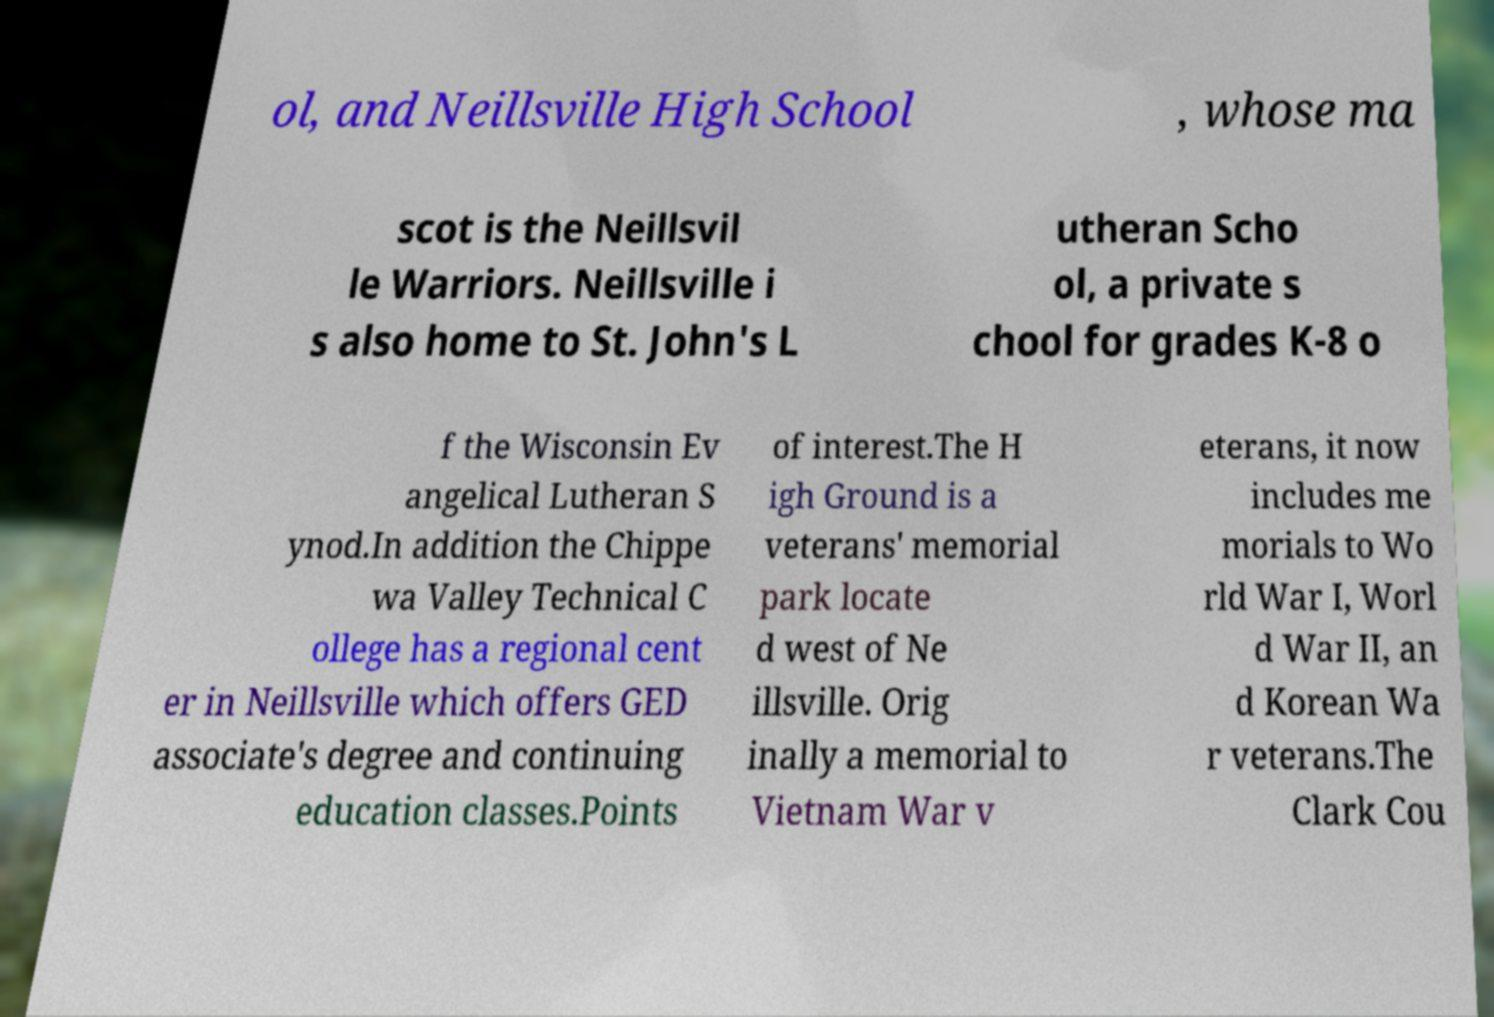Could you assist in decoding the text presented in this image and type it out clearly? ol, and Neillsville High School , whose ma scot is the Neillsvil le Warriors. Neillsville i s also home to St. John's L utheran Scho ol, a private s chool for grades K-8 o f the Wisconsin Ev angelical Lutheran S ynod.In addition the Chippe wa Valley Technical C ollege has a regional cent er in Neillsville which offers GED associate's degree and continuing education classes.Points of interest.The H igh Ground is a veterans' memorial park locate d west of Ne illsville. Orig inally a memorial to Vietnam War v eterans, it now includes me morials to Wo rld War I, Worl d War II, an d Korean Wa r veterans.The Clark Cou 